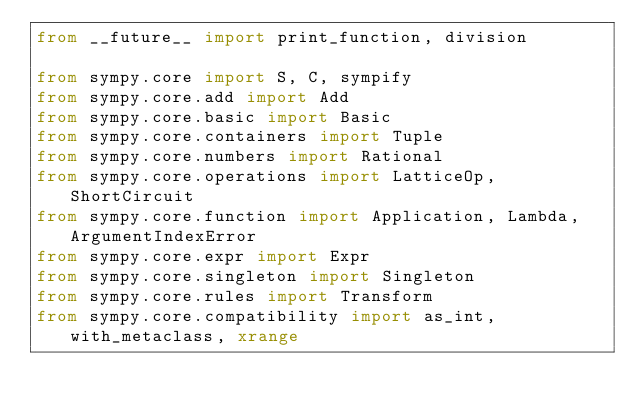<code> <loc_0><loc_0><loc_500><loc_500><_Python_>from __future__ import print_function, division

from sympy.core import S, C, sympify
from sympy.core.add import Add
from sympy.core.basic import Basic
from sympy.core.containers import Tuple
from sympy.core.numbers import Rational
from sympy.core.operations import LatticeOp, ShortCircuit
from sympy.core.function import Application, Lambda, ArgumentIndexError
from sympy.core.expr import Expr
from sympy.core.singleton import Singleton
from sympy.core.rules import Transform
from sympy.core.compatibility import as_int, with_metaclass, xrange</code> 